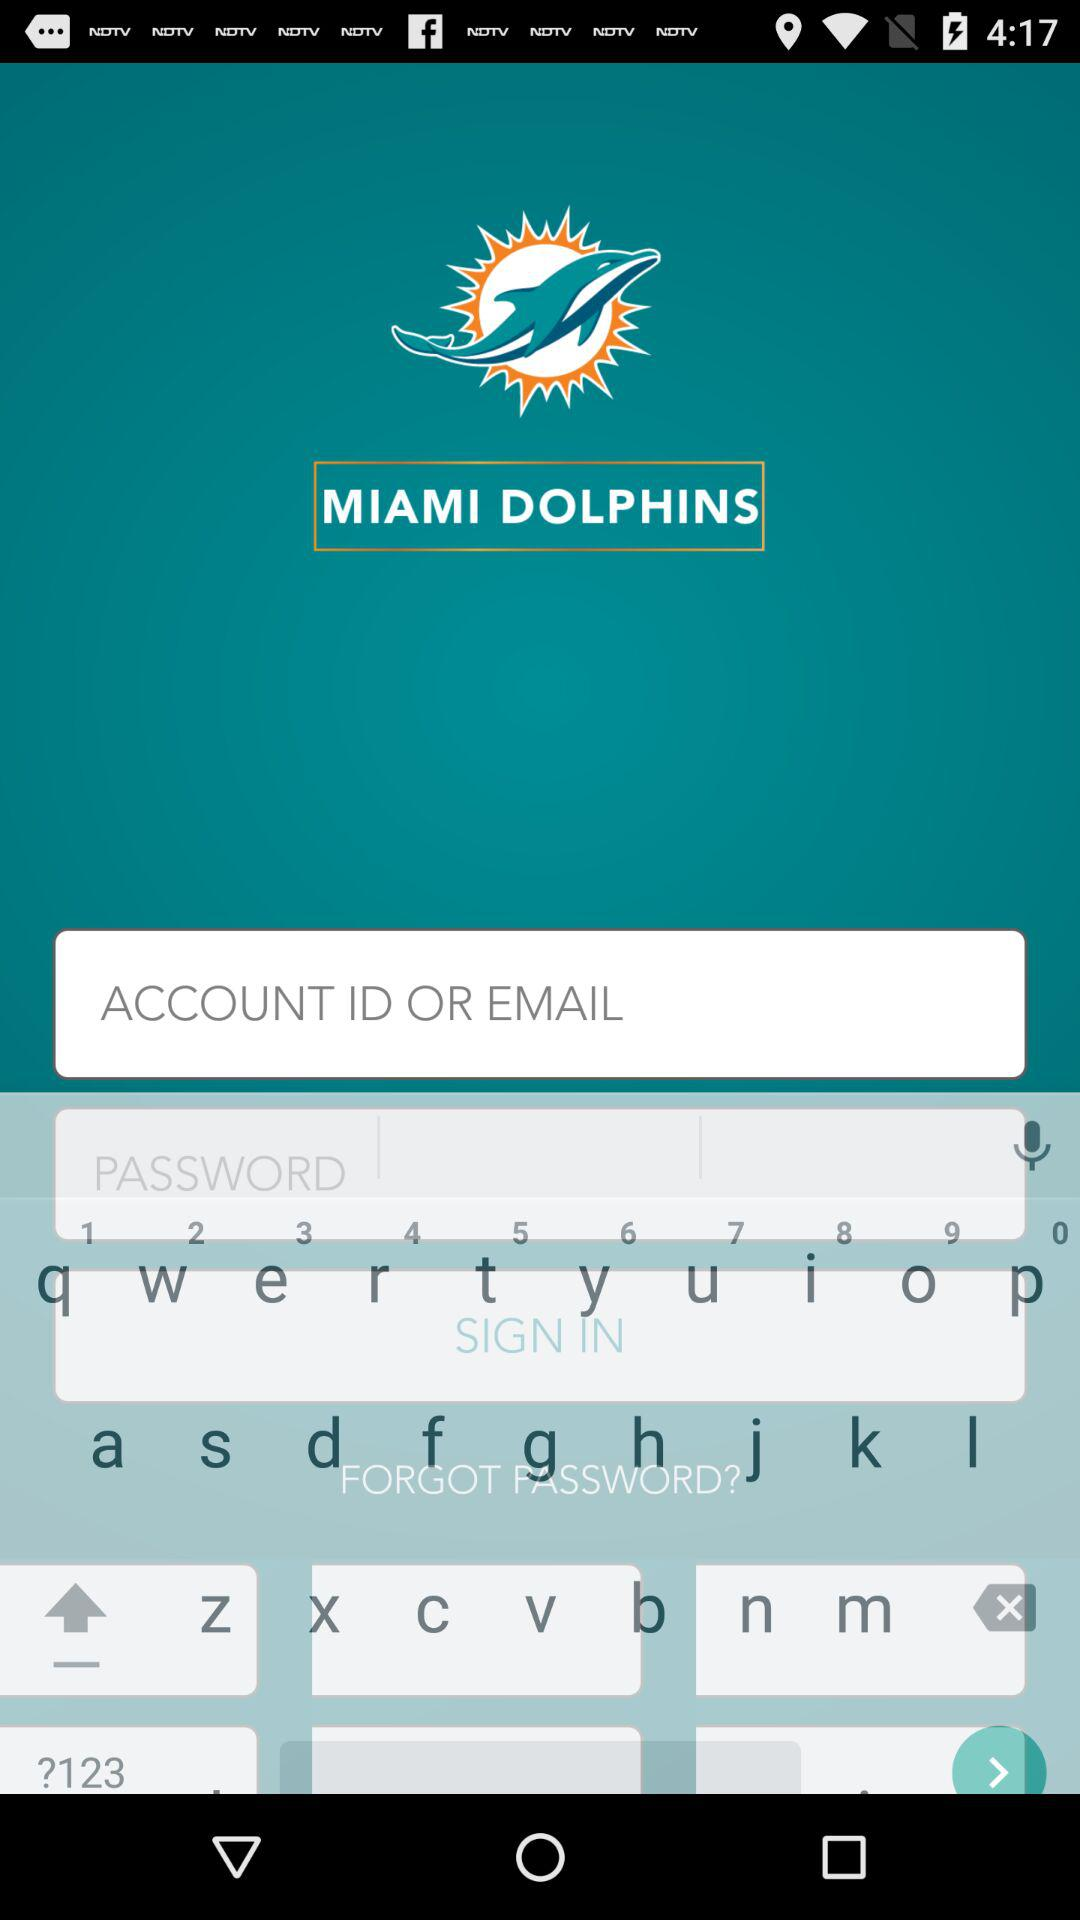With which number does the zip code start?
When the provided information is insufficient, respond with <no answer>. <no answer> 